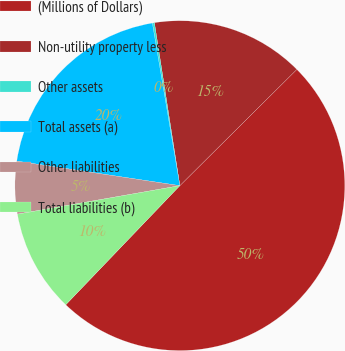<chart> <loc_0><loc_0><loc_500><loc_500><pie_chart><fcel>(Millions of Dollars)<fcel>Non-utility property less<fcel>Other assets<fcel>Total assets (a)<fcel>Other liabilities<fcel>Total liabilities (b)<nl><fcel>49.61%<fcel>15.02%<fcel>0.2%<fcel>19.96%<fcel>5.14%<fcel>10.08%<nl></chart> 